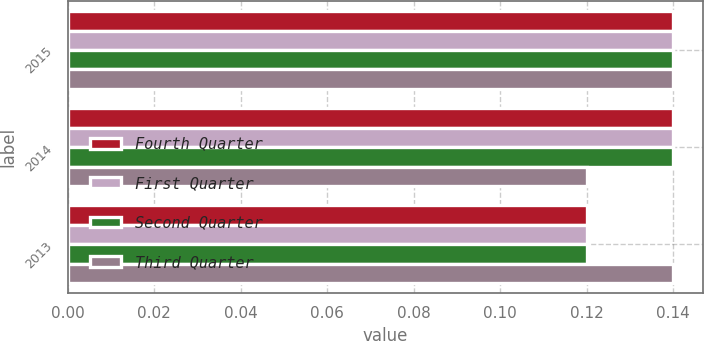Convert chart. <chart><loc_0><loc_0><loc_500><loc_500><stacked_bar_chart><ecel><fcel>2015<fcel>2014<fcel>2013<nl><fcel>Fourth Quarter<fcel>0.14<fcel>0.14<fcel>0.12<nl><fcel>First Quarter<fcel>0.14<fcel>0.14<fcel>0.12<nl><fcel>Second Quarter<fcel>0.14<fcel>0.14<fcel>0.12<nl><fcel>Third Quarter<fcel>0.14<fcel>0.12<fcel>0.14<nl></chart> 